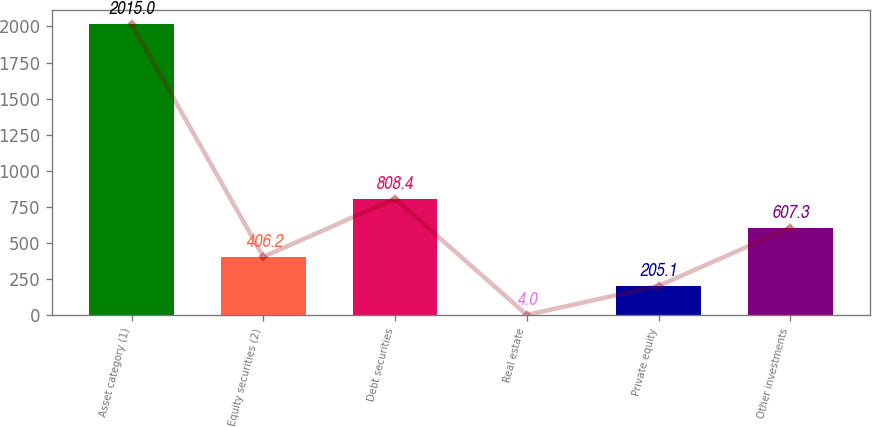<chart> <loc_0><loc_0><loc_500><loc_500><bar_chart><fcel>Asset category (1)<fcel>Equity securities (2)<fcel>Debt securities<fcel>Real estate<fcel>Private equity<fcel>Other investments<nl><fcel>2015<fcel>406.2<fcel>808.4<fcel>4<fcel>205.1<fcel>607.3<nl></chart> 